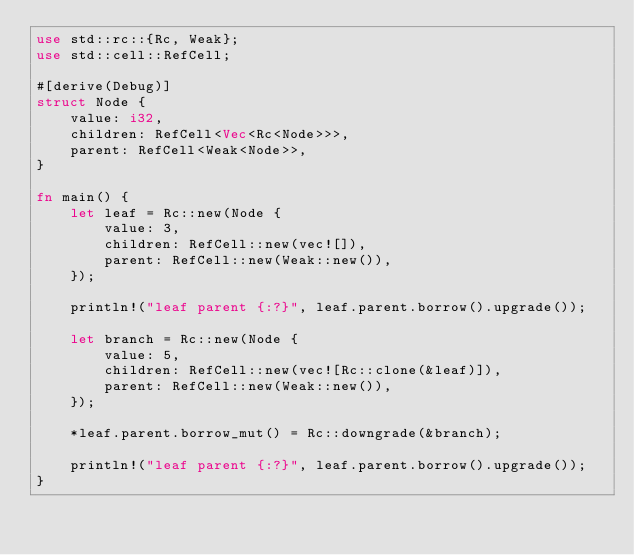Convert code to text. <code><loc_0><loc_0><loc_500><loc_500><_Rust_>use std::rc::{Rc, Weak};
use std::cell::RefCell;

#[derive(Debug)]
struct Node {
    value: i32,
    children: RefCell<Vec<Rc<Node>>>,
    parent: RefCell<Weak<Node>>,
}

fn main() {
    let leaf = Rc::new(Node {
        value: 3,
        children: RefCell::new(vec![]),
        parent: RefCell::new(Weak::new()),
    });

    println!("leaf parent {:?}", leaf.parent.borrow().upgrade());

    let branch = Rc::new(Node {
        value: 5,
        children: RefCell::new(vec![Rc::clone(&leaf)]),
        parent: RefCell::new(Weak::new()),
    });

    *leaf.parent.borrow_mut() = Rc::downgrade(&branch);

    println!("leaf parent {:?}", leaf.parent.borrow().upgrade());
}
</code> 